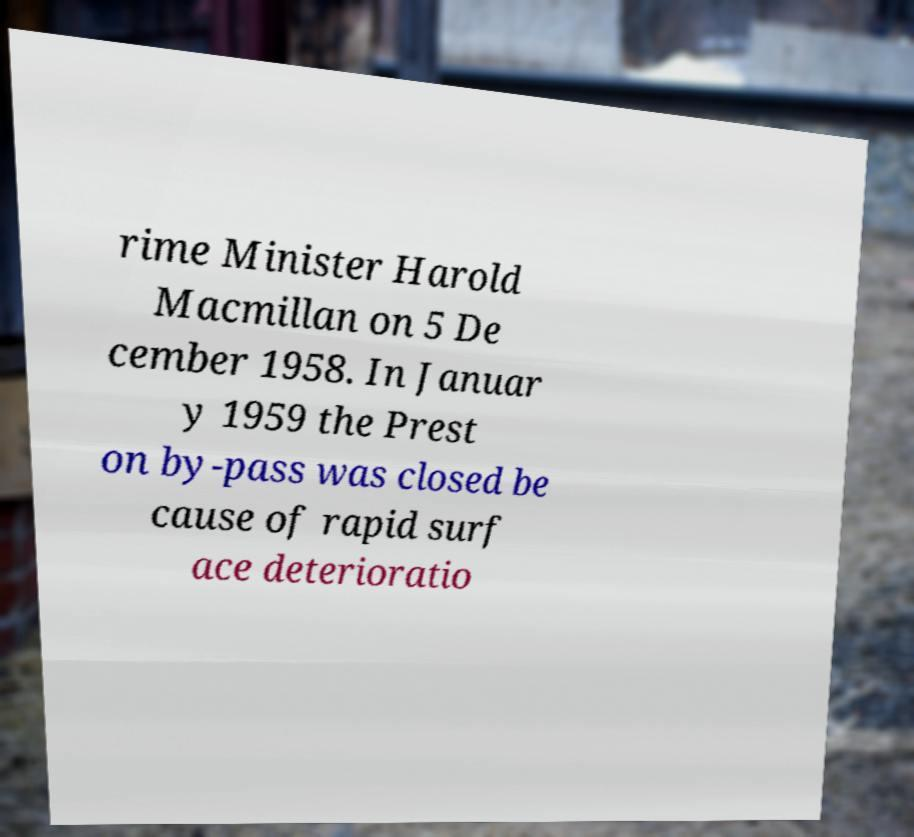Could you assist in decoding the text presented in this image and type it out clearly? rime Minister Harold Macmillan on 5 De cember 1958. In Januar y 1959 the Prest on by-pass was closed be cause of rapid surf ace deterioratio 